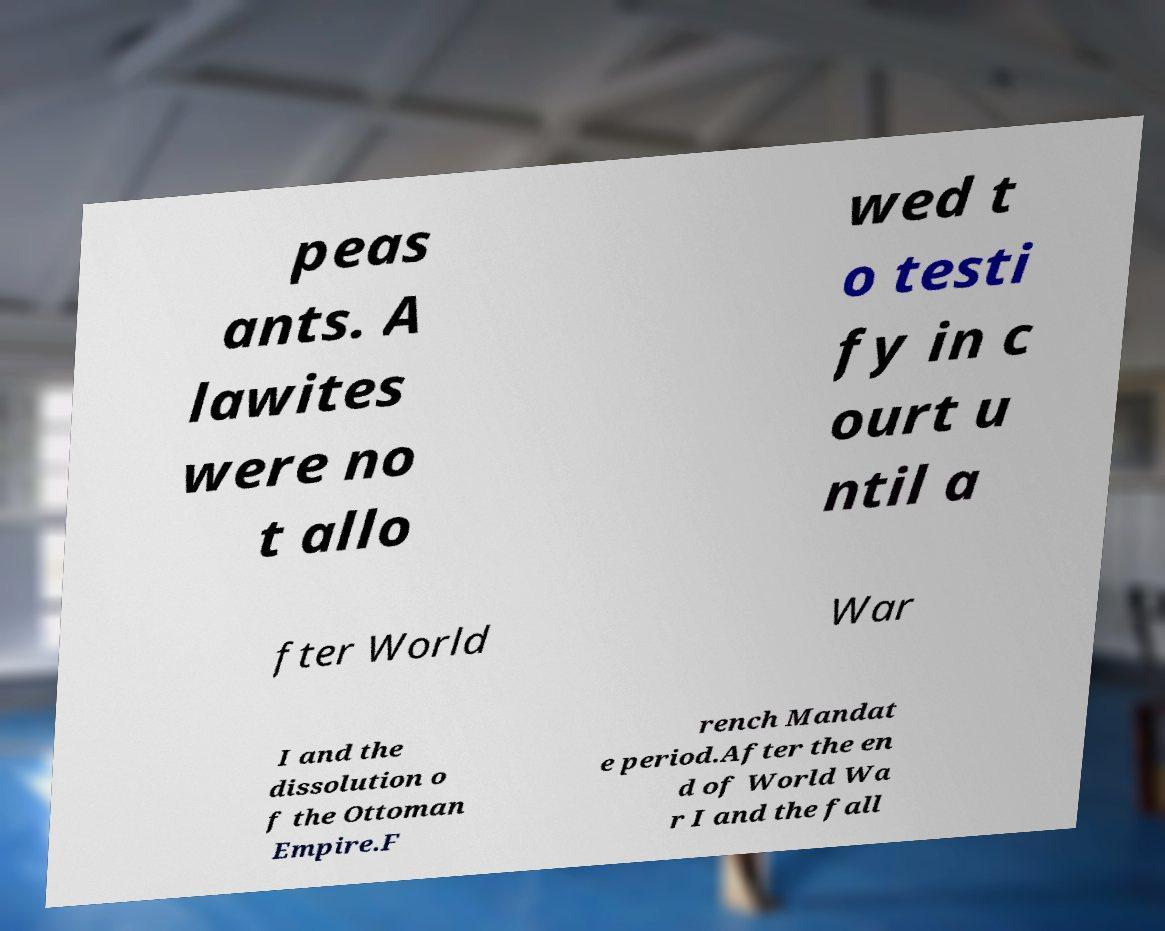Please read and relay the text visible in this image. What does it say? peas ants. A lawites were no t allo wed t o testi fy in c ourt u ntil a fter World War I and the dissolution o f the Ottoman Empire.F rench Mandat e period.After the en d of World Wa r I and the fall 